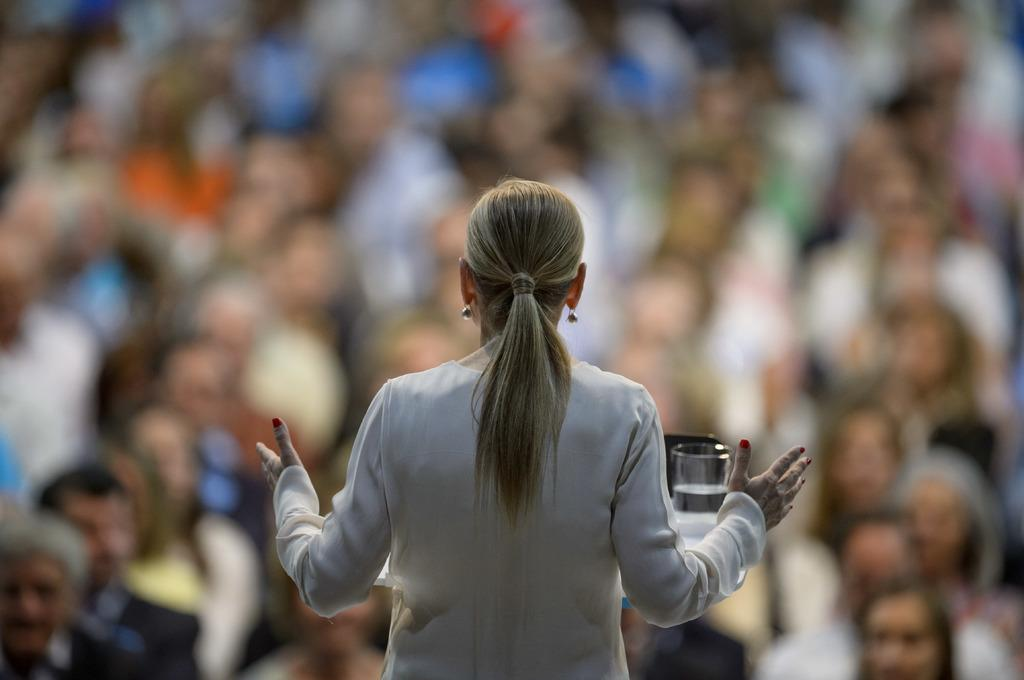What is the main subject of the image? There is a woman standing in the image. What object can be seen on a table in the image? There is a glass of water on a table in the image. How would you describe the background of the image? The background of the image appears blurry. Can you tell me how many people are in the image? There is a group of people in the image. What type of sponge is being used by the woman in the image? There is no sponge visible in the image, and the woman's actions are not described. 